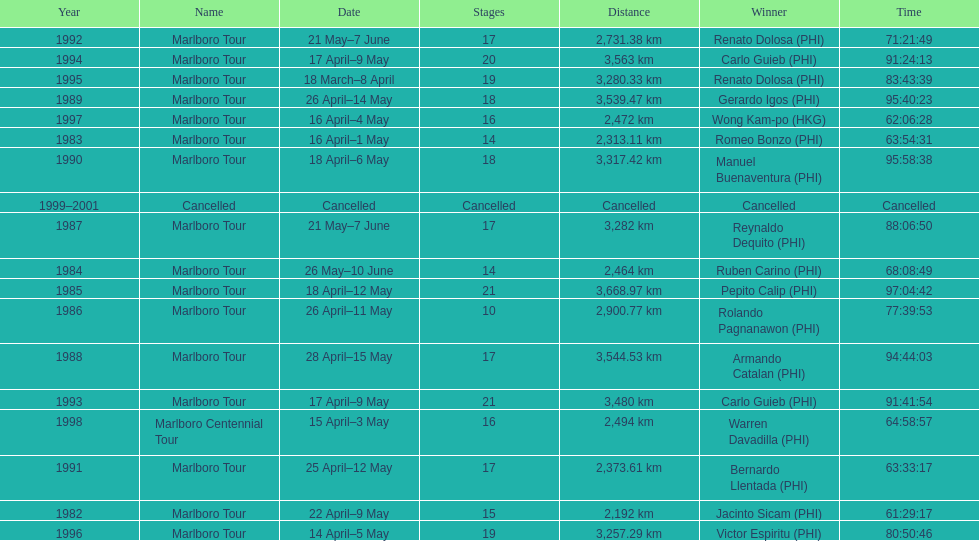What was the largest distance traveled for the marlboro tour? 3,668.97 km. 